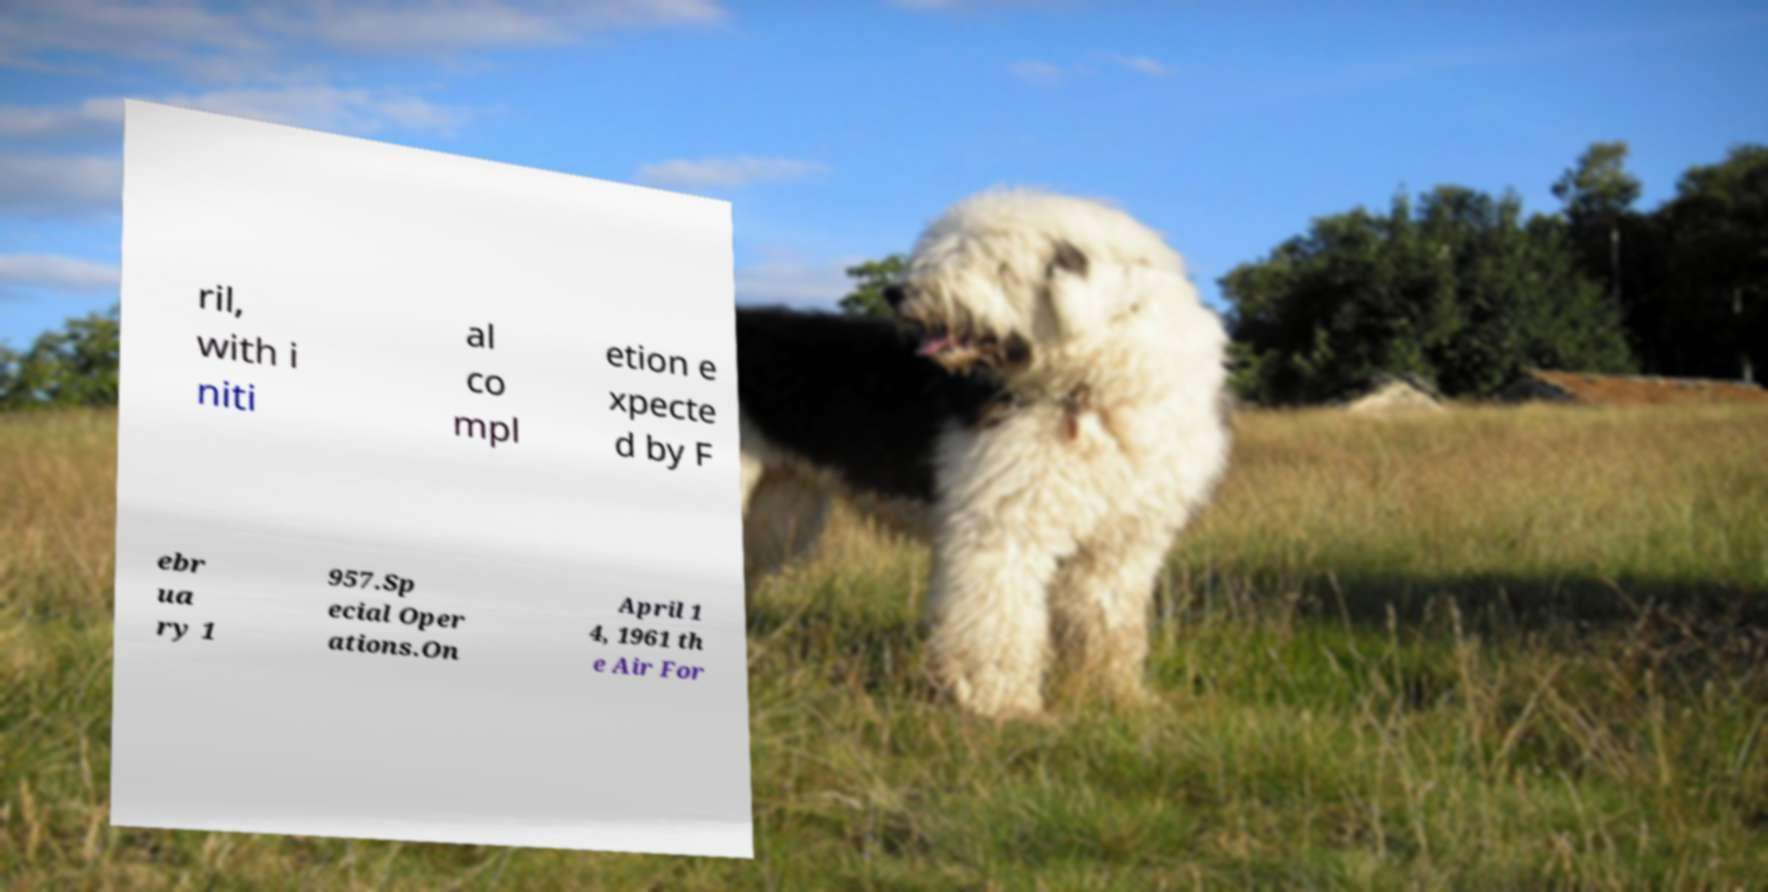For documentation purposes, I need the text within this image transcribed. Could you provide that? ril, with i niti al co mpl etion e xpecte d by F ebr ua ry 1 957.Sp ecial Oper ations.On April 1 4, 1961 th e Air For 